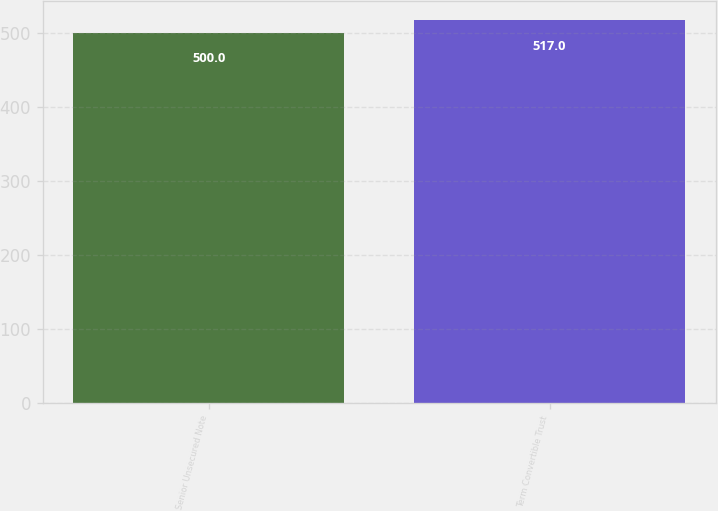Convert chart to OTSL. <chart><loc_0><loc_0><loc_500><loc_500><bar_chart><fcel>Senior Unsecured Note<fcel>Term Convertible Trust<nl><fcel>500<fcel>517<nl></chart> 